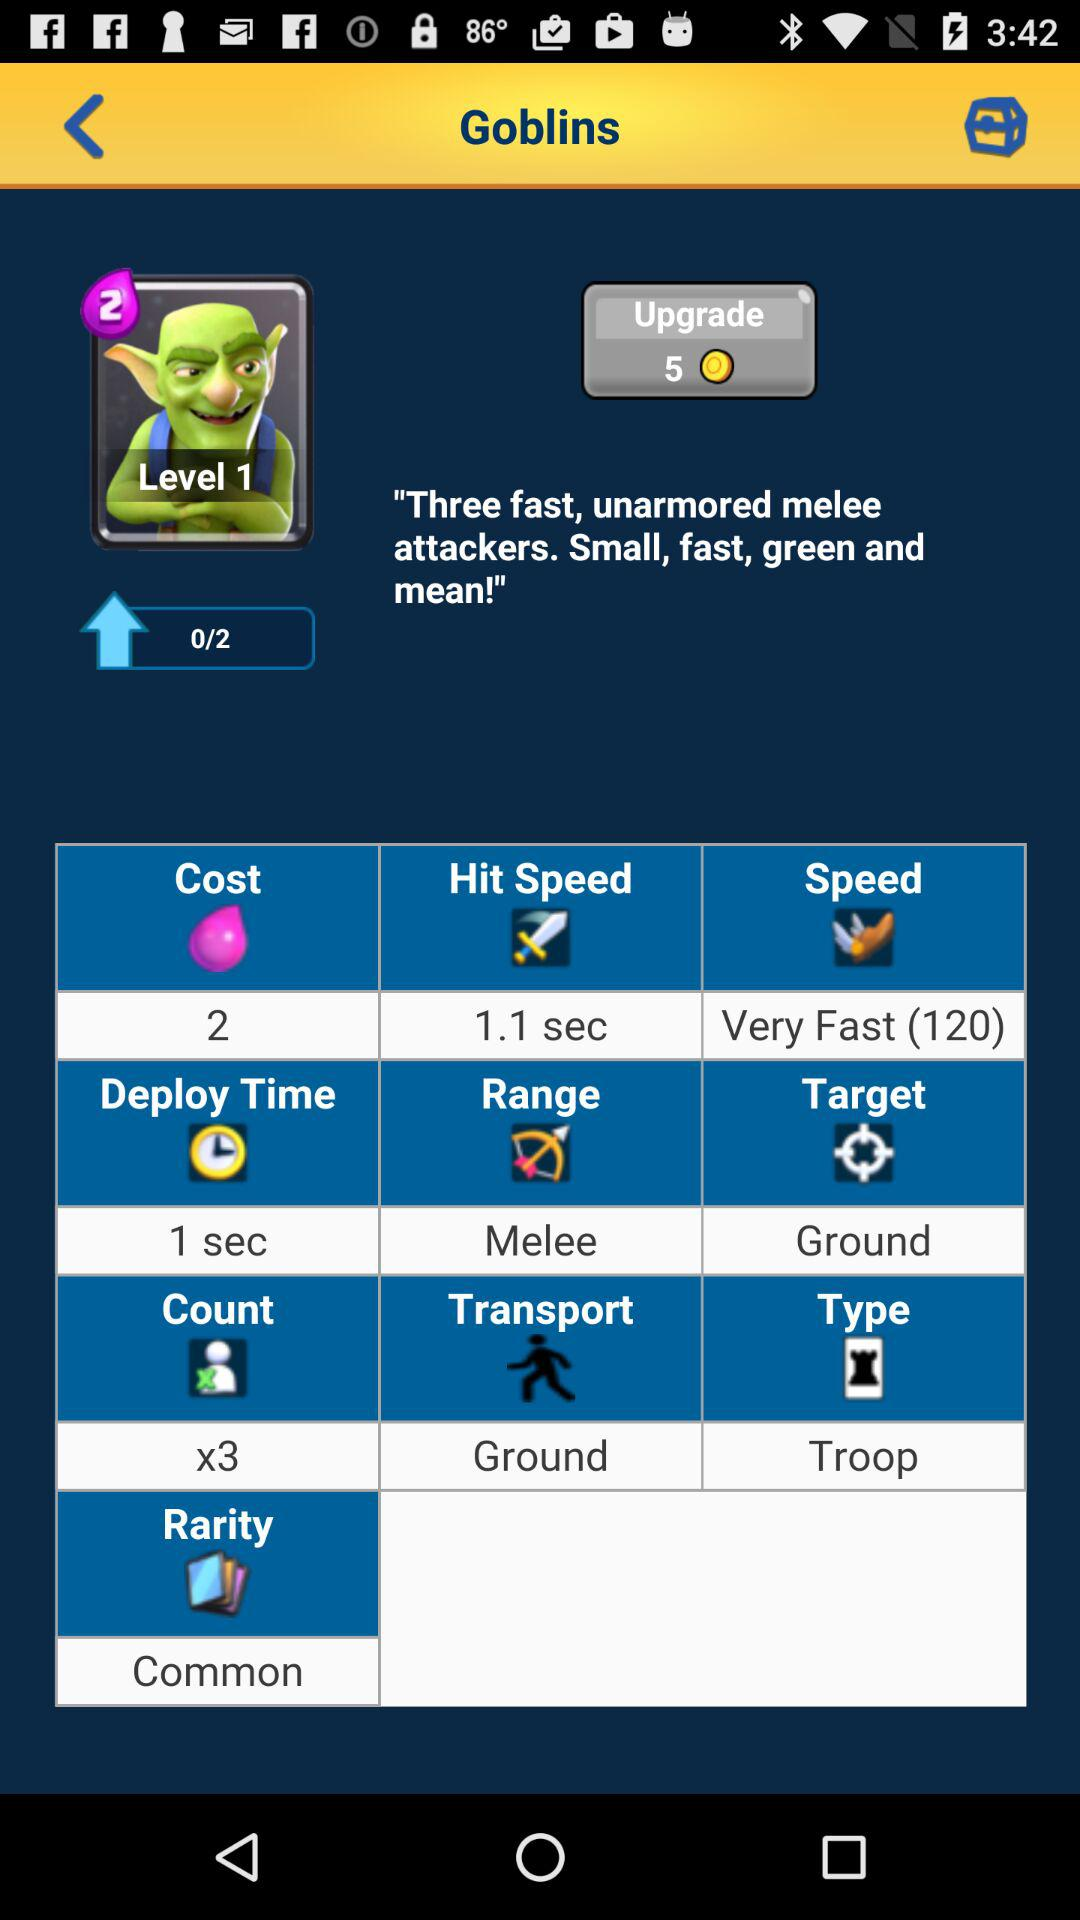What is the current level? The current level is 1. 